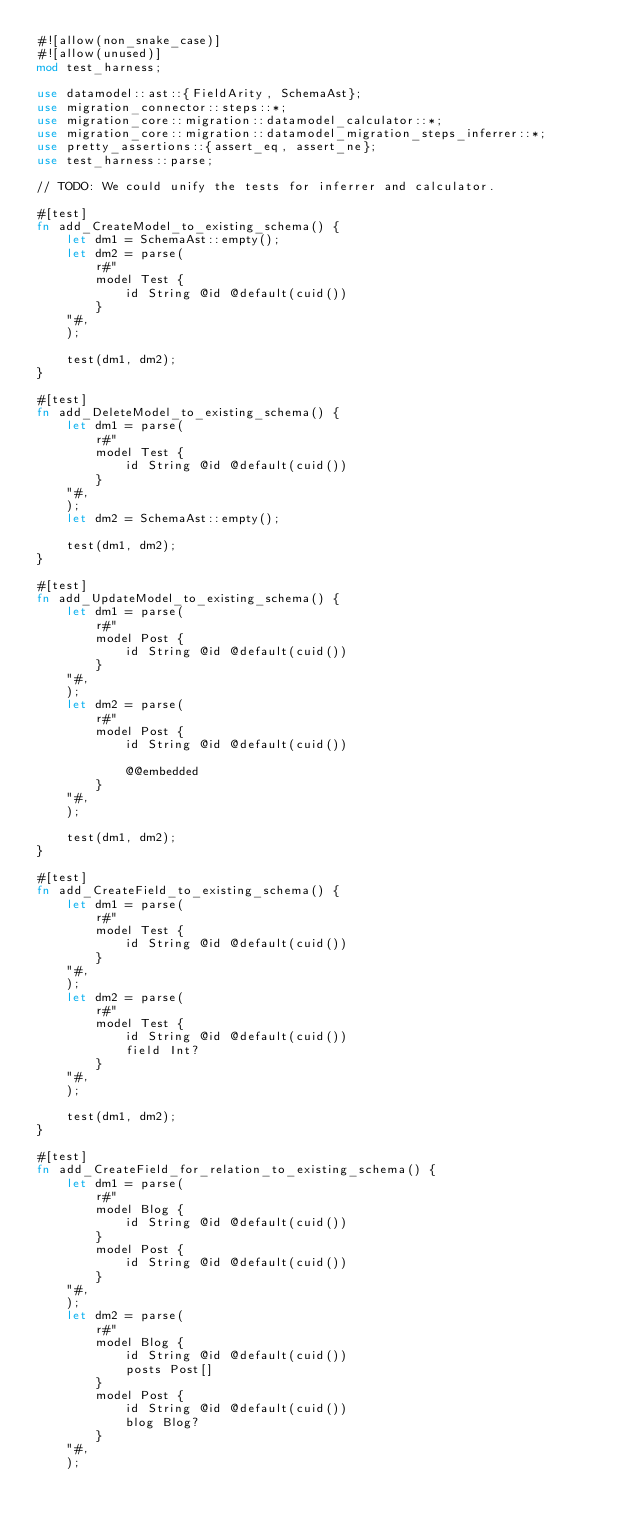Convert code to text. <code><loc_0><loc_0><loc_500><loc_500><_Rust_>#![allow(non_snake_case)]
#![allow(unused)]
mod test_harness;

use datamodel::ast::{FieldArity, SchemaAst};
use migration_connector::steps::*;
use migration_core::migration::datamodel_calculator::*;
use migration_core::migration::datamodel_migration_steps_inferrer::*;
use pretty_assertions::{assert_eq, assert_ne};
use test_harness::parse;

// TODO: We could unify the tests for inferrer and calculator.

#[test]
fn add_CreateModel_to_existing_schema() {
    let dm1 = SchemaAst::empty();
    let dm2 = parse(
        r#"
        model Test {
            id String @id @default(cuid())
        }
    "#,
    );

    test(dm1, dm2);
}

#[test]
fn add_DeleteModel_to_existing_schema() {
    let dm1 = parse(
        r#"
        model Test {
            id String @id @default(cuid())
        }
    "#,
    );
    let dm2 = SchemaAst::empty();

    test(dm1, dm2);
}

#[test]
fn add_UpdateModel_to_existing_schema() {
    let dm1 = parse(
        r#"
        model Post {
            id String @id @default(cuid())
        }
    "#,
    );
    let dm2 = parse(
        r#"
        model Post {
            id String @id @default(cuid())

            @@embedded
        }
    "#,
    );

    test(dm1, dm2);
}

#[test]
fn add_CreateField_to_existing_schema() {
    let dm1 = parse(
        r#"
        model Test {
            id String @id @default(cuid())
        }
    "#,
    );
    let dm2 = parse(
        r#"
        model Test {
            id String @id @default(cuid())
            field Int?
        }
    "#,
    );

    test(dm1, dm2);
}

#[test]
fn add_CreateField_for_relation_to_existing_schema() {
    let dm1 = parse(
        r#"
        model Blog {
            id String @id @default(cuid())
        }
        model Post {
            id String @id @default(cuid())
        }
    "#,
    );
    let dm2 = parse(
        r#"
        model Blog {
            id String @id @default(cuid())
            posts Post[]
        }
        model Post {
            id String @id @default(cuid())
            blog Blog?
        }
    "#,
    );
</code> 